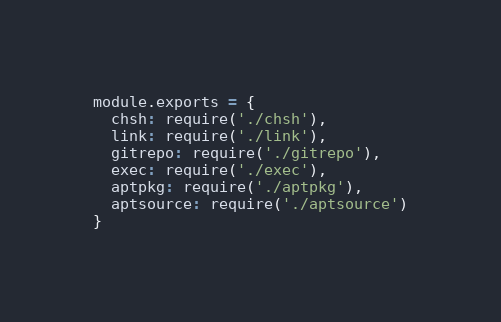Convert code to text. <code><loc_0><loc_0><loc_500><loc_500><_JavaScript_>module.exports = {
  chsh: require('./chsh'),
  link: require('./link'),
  gitrepo: require('./gitrepo'),
  exec: require('./exec'),
  aptpkg: require('./aptpkg'),
  aptsource: require('./aptsource')
}
</code> 